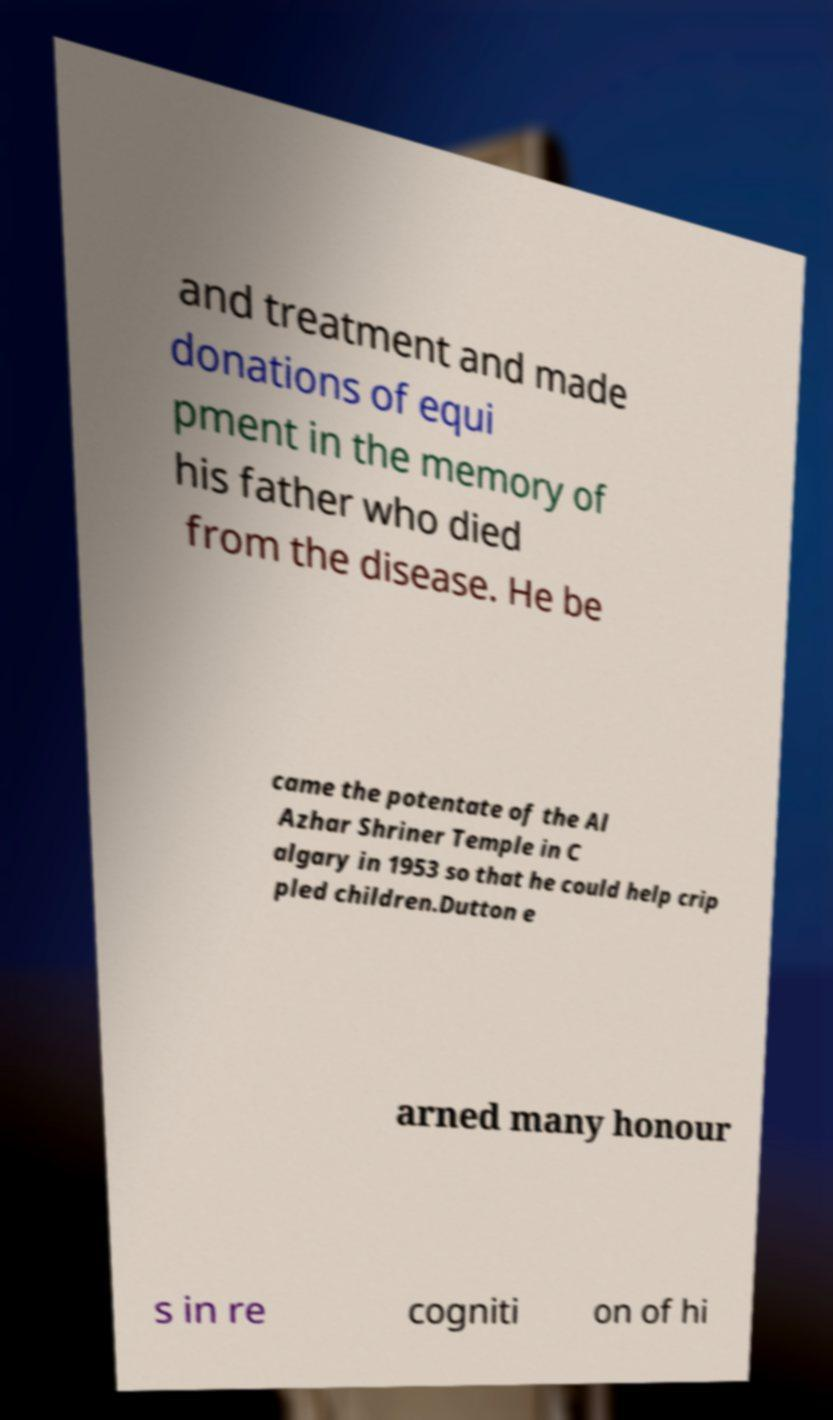What messages or text are displayed in this image? I need them in a readable, typed format. and treatment and made donations of equi pment in the memory of his father who died from the disease. He be came the potentate of the Al Azhar Shriner Temple in C algary in 1953 so that he could help crip pled children.Dutton e arned many honour s in re cogniti on of hi 